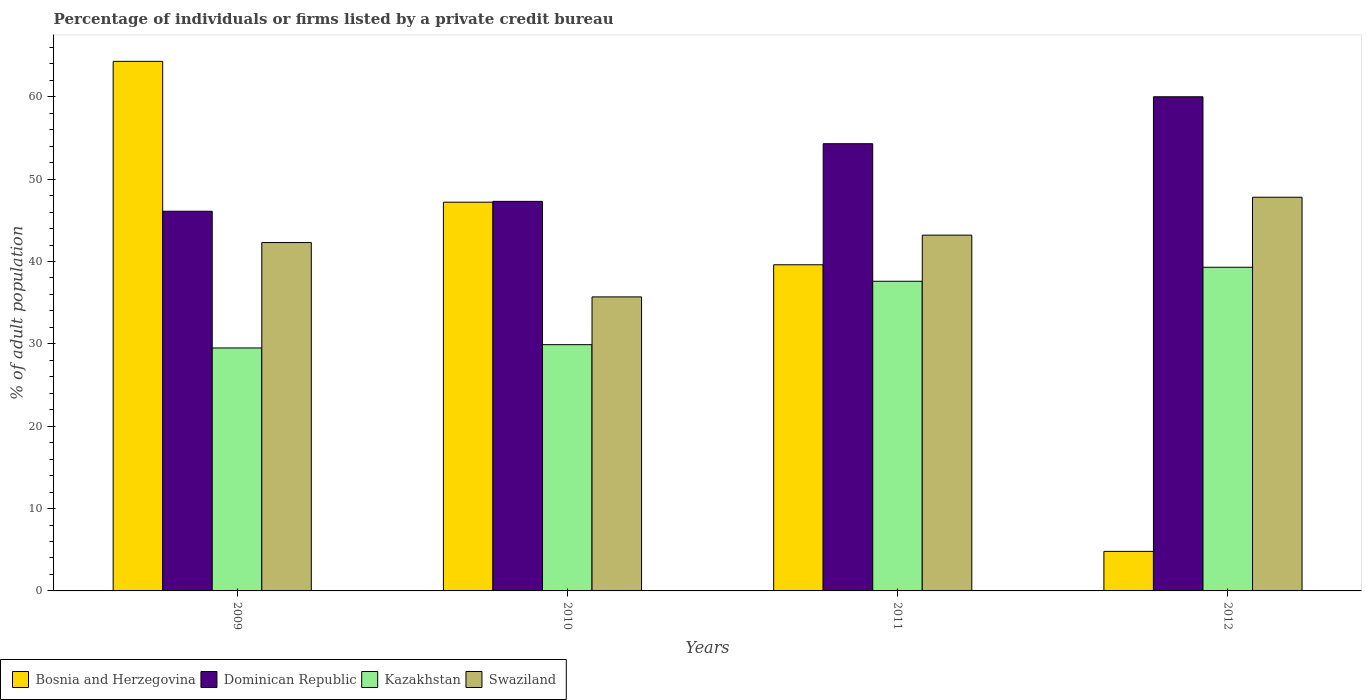How many different coloured bars are there?
Your response must be concise. 4. How many groups of bars are there?
Give a very brief answer. 4. Are the number of bars on each tick of the X-axis equal?
Make the answer very short. Yes. How many bars are there on the 2nd tick from the left?
Ensure brevity in your answer.  4. What is the label of the 2nd group of bars from the left?
Keep it short and to the point. 2010. In how many cases, is the number of bars for a given year not equal to the number of legend labels?
Make the answer very short. 0. What is the percentage of population listed by a private credit bureau in Bosnia and Herzegovina in 2010?
Offer a very short reply. 47.2. Across all years, what is the maximum percentage of population listed by a private credit bureau in Swaziland?
Offer a very short reply. 47.8. In which year was the percentage of population listed by a private credit bureau in Kazakhstan maximum?
Make the answer very short. 2012. In which year was the percentage of population listed by a private credit bureau in Swaziland minimum?
Ensure brevity in your answer.  2010. What is the total percentage of population listed by a private credit bureau in Dominican Republic in the graph?
Provide a short and direct response. 207.7. What is the difference between the percentage of population listed by a private credit bureau in Swaziland in 2009 and that in 2011?
Your answer should be very brief. -0.9. What is the difference between the percentage of population listed by a private credit bureau in Bosnia and Herzegovina in 2011 and the percentage of population listed by a private credit bureau in Swaziland in 2012?
Offer a very short reply. -8.2. What is the average percentage of population listed by a private credit bureau in Kazakhstan per year?
Offer a very short reply. 34.08. In the year 2011, what is the difference between the percentage of population listed by a private credit bureau in Dominican Republic and percentage of population listed by a private credit bureau in Bosnia and Herzegovina?
Your answer should be very brief. 14.7. In how many years, is the percentage of population listed by a private credit bureau in Swaziland greater than 58 %?
Offer a terse response. 0. What is the ratio of the percentage of population listed by a private credit bureau in Bosnia and Herzegovina in 2010 to that in 2011?
Your response must be concise. 1.19. Is the percentage of population listed by a private credit bureau in Kazakhstan in 2009 less than that in 2012?
Offer a terse response. Yes. Is the difference between the percentage of population listed by a private credit bureau in Dominican Republic in 2009 and 2011 greater than the difference between the percentage of population listed by a private credit bureau in Bosnia and Herzegovina in 2009 and 2011?
Offer a terse response. No. What is the difference between the highest and the second highest percentage of population listed by a private credit bureau in Swaziland?
Make the answer very short. 4.6. What is the difference between the highest and the lowest percentage of population listed by a private credit bureau in Swaziland?
Give a very brief answer. 12.1. In how many years, is the percentage of population listed by a private credit bureau in Bosnia and Herzegovina greater than the average percentage of population listed by a private credit bureau in Bosnia and Herzegovina taken over all years?
Provide a short and direct response. 3. Is the sum of the percentage of population listed by a private credit bureau in Dominican Republic in 2009 and 2011 greater than the maximum percentage of population listed by a private credit bureau in Bosnia and Herzegovina across all years?
Give a very brief answer. Yes. Is it the case that in every year, the sum of the percentage of population listed by a private credit bureau in Bosnia and Herzegovina and percentage of population listed by a private credit bureau in Dominican Republic is greater than the sum of percentage of population listed by a private credit bureau in Kazakhstan and percentage of population listed by a private credit bureau in Swaziland?
Offer a very short reply. No. What does the 4th bar from the left in 2009 represents?
Offer a terse response. Swaziland. What does the 3rd bar from the right in 2010 represents?
Provide a short and direct response. Dominican Republic. How many years are there in the graph?
Make the answer very short. 4. Does the graph contain any zero values?
Your answer should be compact. No. Where does the legend appear in the graph?
Make the answer very short. Bottom left. What is the title of the graph?
Your answer should be very brief. Percentage of individuals or firms listed by a private credit bureau. Does "Slovenia" appear as one of the legend labels in the graph?
Make the answer very short. No. What is the label or title of the X-axis?
Ensure brevity in your answer.  Years. What is the label or title of the Y-axis?
Keep it short and to the point. % of adult population. What is the % of adult population in Bosnia and Herzegovina in 2009?
Your answer should be compact. 64.3. What is the % of adult population of Dominican Republic in 2009?
Your answer should be very brief. 46.1. What is the % of adult population in Kazakhstan in 2009?
Provide a succinct answer. 29.5. What is the % of adult population of Swaziland in 2009?
Make the answer very short. 42.3. What is the % of adult population of Bosnia and Herzegovina in 2010?
Your response must be concise. 47.2. What is the % of adult population in Dominican Republic in 2010?
Your answer should be compact. 47.3. What is the % of adult population of Kazakhstan in 2010?
Offer a terse response. 29.9. What is the % of adult population in Swaziland in 2010?
Provide a succinct answer. 35.7. What is the % of adult population of Bosnia and Herzegovina in 2011?
Offer a terse response. 39.6. What is the % of adult population in Dominican Republic in 2011?
Your answer should be compact. 54.3. What is the % of adult population of Kazakhstan in 2011?
Ensure brevity in your answer.  37.6. What is the % of adult population of Swaziland in 2011?
Your answer should be compact. 43.2. What is the % of adult population in Bosnia and Herzegovina in 2012?
Keep it short and to the point. 4.8. What is the % of adult population in Dominican Republic in 2012?
Offer a terse response. 60. What is the % of adult population of Kazakhstan in 2012?
Ensure brevity in your answer.  39.3. What is the % of adult population in Swaziland in 2012?
Provide a short and direct response. 47.8. Across all years, what is the maximum % of adult population in Bosnia and Herzegovina?
Provide a succinct answer. 64.3. Across all years, what is the maximum % of adult population of Dominican Republic?
Keep it short and to the point. 60. Across all years, what is the maximum % of adult population of Kazakhstan?
Your answer should be very brief. 39.3. Across all years, what is the maximum % of adult population in Swaziland?
Your answer should be compact. 47.8. Across all years, what is the minimum % of adult population of Dominican Republic?
Make the answer very short. 46.1. Across all years, what is the minimum % of adult population of Kazakhstan?
Provide a short and direct response. 29.5. Across all years, what is the minimum % of adult population in Swaziland?
Give a very brief answer. 35.7. What is the total % of adult population in Bosnia and Herzegovina in the graph?
Offer a terse response. 155.9. What is the total % of adult population in Dominican Republic in the graph?
Your answer should be compact. 207.7. What is the total % of adult population in Kazakhstan in the graph?
Ensure brevity in your answer.  136.3. What is the total % of adult population of Swaziland in the graph?
Your answer should be compact. 169. What is the difference between the % of adult population in Bosnia and Herzegovina in 2009 and that in 2010?
Offer a very short reply. 17.1. What is the difference between the % of adult population in Kazakhstan in 2009 and that in 2010?
Your response must be concise. -0.4. What is the difference between the % of adult population of Swaziland in 2009 and that in 2010?
Make the answer very short. 6.6. What is the difference between the % of adult population in Bosnia and Herzegovina in 2009 and that in 2011?
Offer a very short reply. 24.7. What is the difference between the % of adult population in Kazakhstan in 2009 and that in 2011?
Make the answer very short. -8.1. What is the difference between the % of adult population of Swaziland in 2009 and that in 2011?
Your response must be concise. -0.9. What is the difference between the % of adult population of Bosnia and Herzegovina in 2009 and that in 2012?
Offer a terse response. 59.5. What is the difference between the % of adult population of Swaziland in 2009 and that in 2012?
Your response must be concise. -5.5. What is the difference between the % of adult population in Bosnia and Herzegovina in 2010 and that in 2011?
Ensure brevity in your answer.  7.6. What is the difference between the % of adult population in Dominican Republic in 2010 and that in 2011?
Provide a short and direct response. -7. What is the difference between the % of adult population in Kazakhstan in 2010 and that in 2011?
Give a very brief answer. -7.7. What is the difference between the % of adult population of Bosnia and Herzegovina in 2010 and that in 2012?
Your response must be concise. 42.4. What is the difference between the % of adult population in Swaziland in 2010 and that in 2012?
Your answer should be compact. -12.1. What is the difference between the % of adult population of Bosnia and Herzegovina in 2011 and that in 2012?
Make the answer very short. 34.8. What is the difference between the % of adult population of Kazakhstan in 2011 and that in 2012?
Offer a very short reply. -1.7. What is the difference between the % of adult population of Swaziland in 2011 and that in 2012?
Give a very brief answer. -4.6. What is the difference between the % of adult population in Bosnia and Herzegovina in 2009 and the % of adult population in Kazakhstan in 2010?
Offer a terse response. 34.4. What is the difference between the % of adult population of Bosnia and Herzegovina in 2009 and the % of adult population of Swaziland in 2010?
Give a very brief answer. 28.6. What is the difference between the % of adult population in Dominican Republic in 2009 and the % of adult population in Kazakhstan in 2010?
Offer a very short reply. 16.2. What is the difference between the % of adult population of Kazakhstan in 2009 and the % of adult population of Swaziland in 2010?
Make the answer very short. -6.2. What is the difference between the % of adult population in Bosnia and Herzegovina in 2009 and the % of adult population in Dominican Republic in 2011?
Give a very brief answer. 10. What is the difference between the % of adult population of Bosnia and Herzegovina in 2009 and the % of adult population of Kazakhstan in 2011?
Keep it short and to the point. 26.7. What is the difference between the % of adult population of Bosnia and Herzegovina in 2009 and the % of adult population of Swaziland in 2011?
Keep it short and to the point. 21.1. What is the difference between the % of adult population of Kazakhstan in 2009 and the % of adult population of Swaziland in 2011?
Make the answer very short. -13.7. What is the difference between the % of adult population of Bosnia and Herzegovina in 2009 and the % of adult population of Dominican Republic in 2012?
Your response must be concise. 4.3. What is the difference between the % of adult population in Bosnia and Herzegovina in 2009 and the % of adult population in Kazakhstan in 2012?
Your response must be concise. 25. What is the difference between the % of adult population in Bosnia and Herzegovina in 2009 and the % of adult population in Swaziland in 2012?
Provide a succinct answer. 16.5. What is the difference between the % of adult population in Kazakhstan in 2009 and the % of adult population in Swaziland in 2012?
Provide a short and direct response. -18.3. What is the difference between the % of adult population in Dominican Republic in 2010 and the % of adult population in Swaziland in 2011?
Offer a terse response. 4.1. What is the difference between the % of adult population in Kazakhstan in 2010 and the % of adult population in Swaziland in 2011?
Offer a terse response. -13.3. What is the difference between the % of adult population in Dominican Republic in 2010 and the % of adult population in Swaziland in 2012?
Offer a very short reply. -0.5. What is the difference between the % of adult population of Kazakhstan in 2010 and the % of adult population of Swaziland in 2012?
Your answer should be compact. -17.9. What is the difference between the % of adult population of Bosnia and Herzegovina in 2011 and the % of adult population of Dominican Republic in 2012?
Offer a terse response. -20.4. What is the difference between the % of adult population of Bosnia and Herzegovina in 2011 and the % of adult population of Kazakhstan in 2012?
Ensure brevity in your answer.  0.3. What is the difference between the % of adult population in Bosnia and Herzegovina in 2011 and the % of adult population in Swaziland in 2012?
Your answer should be very brief. -8.2. What is the difference between the % of adult population of Dominican Republic in 2011 and the % of adult population of Swaziland in 2012?
Keep it short and to the point. 6.5. What is the difference between the % of adult population in Kazakhstan in 2011 and the % of adult population in Swaziland in 2012?
Your answer should be very brief. -10.2. What is the average % of adult population in Bosnia and Herzegovina per year?
Keep it short and to the point. 38.98. What is the average % of adult population of Dominican Republic per year?
Your answer should be compact. 51.92. What is the average % of adult population in Kazakhstan per year?
Ensure brevity in your answer.  34.08. What is the average % of adult population in Swaziland per year?
Provide a short and direct response. 42.25. In the year 2009, what is the difference between the % of adult population in Bosnia and Herzegovina and % of adult population in Kazakhstan?
Offer a terse response. 34.8. In the year 2009, what is the difference between the % of adult population in Bosnia and Herzegovina and % of adult population in Swaziland?
Offer a terse response. 22. In the year 2009, what is the difference between the % of adult population in Dominican Republic and % of adult population in Swaziland?
Make the answer very short. 3.8. In the year 2009, what is the difference between the % of adult population in Kazakhstan and % of adult population in Swaziland?
Provide a succinct answer. -12.8. In the year 2010, what is the difference between the % of adult population in Bosnia and Herzegovina and % of adult population in Dominican Republic?
Your answer should be compact. -0.1. In the year 2010, what is the difference between the % of adult population in Bosnia and Herzegovina and % of adult population in Kazakhstan?
Make the answer very short. 17.3. In the year 2010, what is the difference between the % of adult population in Bosnia and Herzegovina and % of adult population in Swaziland?
Offer a very short reply. 11.5. In the year 2010, what is the difference between the % of adult population of Dominican Republic and % of adult population of Kazakhstan?
Ensure brevity in your answer.  17.4. In the year 2010, what is the difference between the % of adult population in Dominican Republic and % of adult population in Swaziland?
Make the answer very short. 11.6. In the year 2011, what is the difference between the % of adult population of Bosnia and Herzegovina and % of adult population of Dominican Republic?
Provide a short and direct response. -14.7. In the year 2011, what is the difference between the % of adult population of Bosnia and Herzegovina and % of adult population of Kazakhstan?
Keep it short and to the point. 2. In the year 2011, what is the difference between the % of adult population of Dominican Republic and % of adult population of Kazakhstan?
Make the answer very short. 16.7. In the year 2011, what is the difference between the % of adult population of Kazakhstan and % of adult population of Swaziland?
Offer a very short reply. -5.6. In the year 2012, what is the difference between the % of adult population of Bosnia and Herzegovina and % of adult population of Dominican Republic?
Your answer should be compact. -55.2. In the year 2012, what is the difference between the % of adult population of Bosnia and Herzegovina and % of adult population of Kazakhstan?
Provide a succinct answer. -34.5. In the year 2012, what is the difference between the % of adult population of Bosnia and Herzegovina and % of adult population of Swaziland?
Provide a succinct answer. -43. In the year 2012, what is the difference between the % of adult population of Dominican Republic and % of adult population of Kazakhstan?
Your answer should be very brief. 20.7. In the year 2012, what is the difference between the % of adult population of Dominican Republic and % of adult population of Swaziland?
Provide a succinct answer. 12.2. In the year 2012, what is the difference between the % of adult population of Kazakhstan and % of adult population of Swaziland?
Make the answer very short. -8.5. What is the ratio of the % of adult population of Bosnia and Herzegovina in 2009 to that in 2010?
Provide a short and direct response. 1.36. What is the ratio of the % of adult population of Dominican Republic in 2009 to that in 2010?
Provide a succinct answer. 0.97. What is the ratio of the % of adult population of Kazakhstan in 2009 to that in 2010?
Give a very brief answer. 0.99. What is the ratio of the % of adult population of Swaziland in 2009 to that in 2010?
Keep it short and to the point. 1.18. What is the ratio of the % of adult population in Bosnia and Herzegovina in 2009 to that in 2011?
Keep it short and to the point. 1.62. What is the ratio of the % of adult population of Dominican Republic in 2009 to that in 2011?
Your response must be concise. 0.85. What is the ratio of the % of adult population of Kazakhstan in 2009 to that in 2011?
Make the answer very short. 0.78. What is the ratio of the % of adult population in Swaziland in 2009 to that in 2011?
Your answer should be compact. 0.98. What is the ratio of the % of adult population in Bosnia and Herzegovina in 2009 to that in 2012?
Offer a terse response. 13.4. What is the ratio of the % of adult population in Dominican Republic in 2009 to that in 2012?
Provide a succinct answer. 0.77. What is the ratio of the % of adult population in Kazakhstan in 2009 to that in 2012?
Your answer should be compact. 0.75. What is the ratio of the % of adult population in Swaziland in 2009 to that in 2012?
Provide a short and direct response. 0.88. What is the ratio of the % of adult population in Bosnia and Herzegovina in 2010 to that in 2011?
Your answer should be very brief. 1.19. What is the ratio of the % of adult population in Dominican Republic in 2010 to that in 2011?
Make the answer very short. 0.87. What is the ratio of the % of adult population of Kazakhstan in 2010 to that in 2011?
Your response must be concise. 0.8. What is the ratio of the % of adult population in Swaziland in 2010 to that in 2011?
Make the answer very short. 0.83. What is the ratio of the % of adult population of Bosnia and Herzegovina in 2010 to that in 2012?
Keep it short and to the point. 9.83. What is the ratio of the % of adult population of Dominican Republic in 2010 to that in 2012?
Make the answer very short. 0.79. What is the ratio of the % of adult population of Kazakhstan in 2010 to that in 2012?
Offer a terse response. 0.76. What is the ratio of the % of adult population of Swaziland in 2010 to that in 2012?
Offer a very short reply. 0.75. What is the ratio of the % of adult population in Bosnia and Herzegovina in 2011 to that in 2012?
Offer a terse response. 8.25. What is the ratio of the % of adult population of Dominican Republic in 2011 to that in 2012?
Your answer should be compact. 0.91. What is the ratio of the % of adult population in Kazakhstan in 2011 to that in 2012?
Ensure brevity in your answer.  0.96. What is the ratio of the % of adult population in Swaziland in 2011 to that in 2012?
Keep it short and to the point. 0.9. What is the difference between the highest and the second highest % of adult population of Kazakhstan?
Your answer should be compact. 1.7. What is the difference between the highest and the lowest % of adult population in Bosnia and Herzegovina?
Your answer should be very brief. 59.5. What is the difference between the highest and the lowest % of adult population in Kazakhstan?
Give a very brief answer. 9.8. 